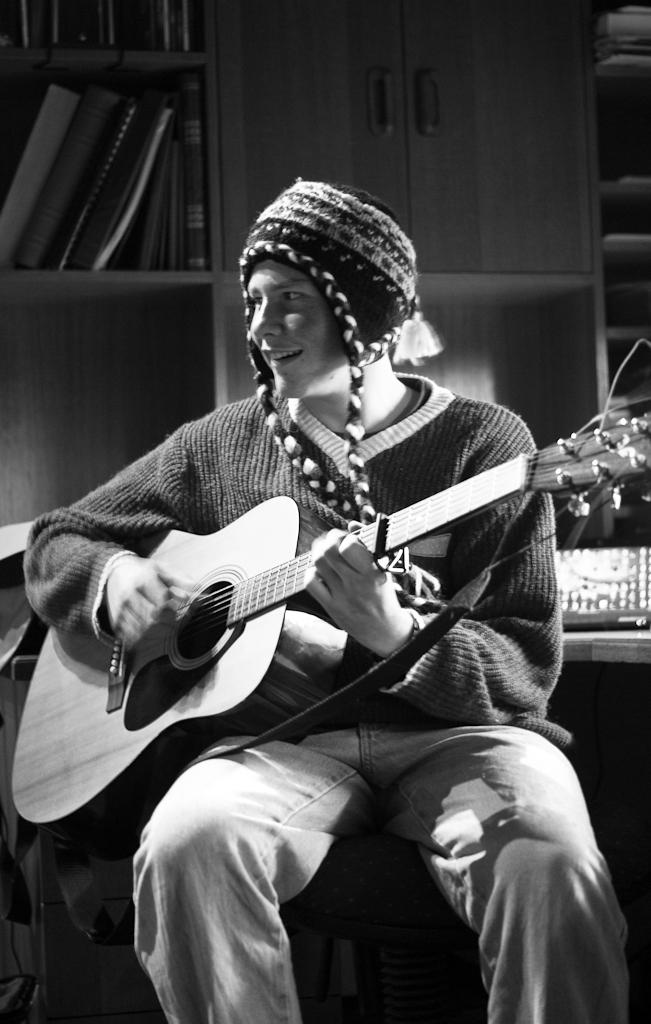What is the person in the image doing? A human is playing a musical instrument in the image. How does the person appear to feel while playing the instrument? The person is smiling. What can be seen in the background of the image? There are cupboards visible in the background. What is inside the cupboards? The cupboards are filled with items. What is the person's position in the image? The man is sitting on a chair. What type of arm is visible on the dinosaur in the image? There are no dinosaurs present in the image, so there is no arm to describe. 